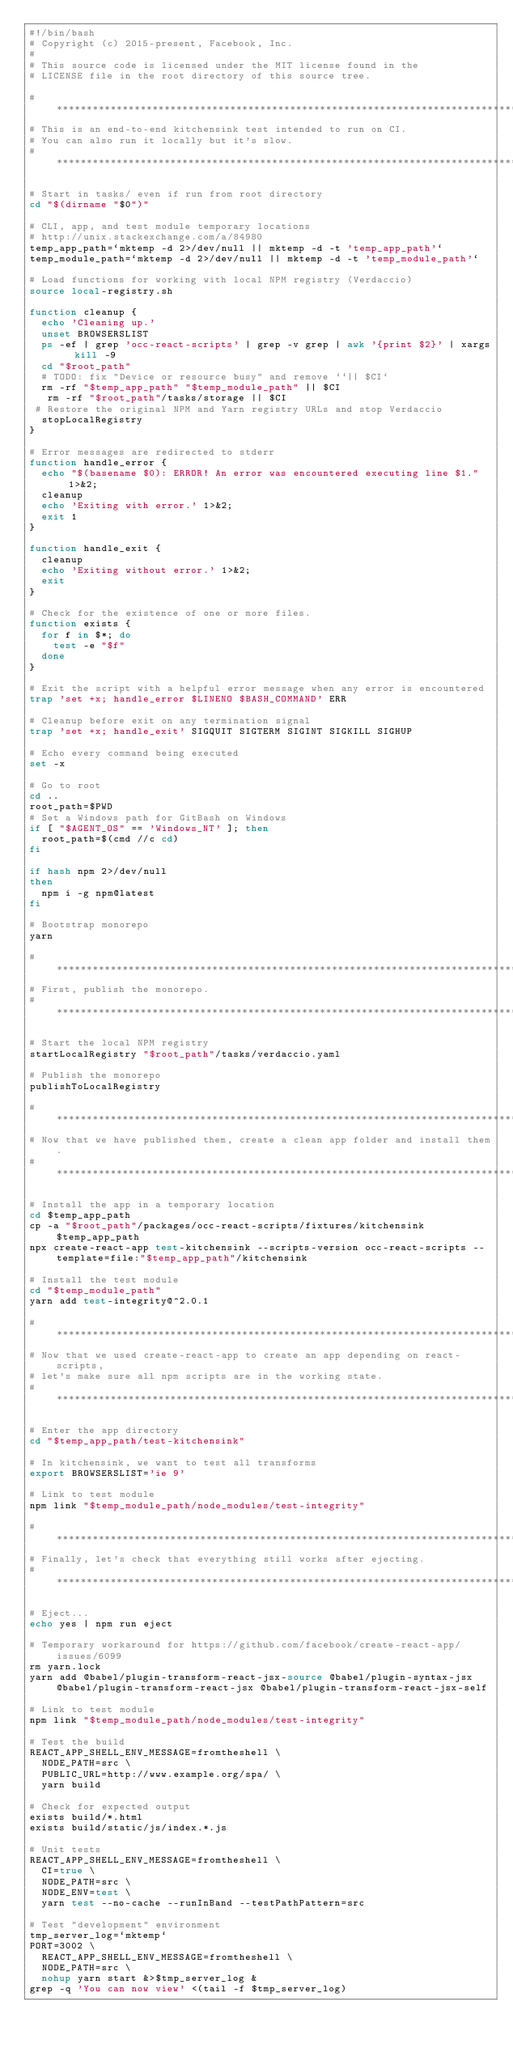<code> <loc_0><loc_0><loc_500><loc_500><_Bash_>#!/bin/bash
# Copyright (c) 2015-present, Facebook, Inc.
#
# This source code is licensed under the MIT license found in the
# LICENSE file in the root directory of this source tree.

# ******************************************************************************
# This is an end-to-end kitchensink test intended to run on CI.
# You can also run it locally but it's slow.
# ******************************************************************************

# Start in tasks/ even if run from root directory
cd "$(dirname "$0")"

# CLI, app, and test module temporary locations
# http://unix.stackexchange.com/a/84980
temp_app_path=`mktemp -d 2>/dev/null || mktemp -d -t 'temp_app_path'`
temp_module_path=`mktemp -d 2>/dev/null || mktemp -d -t 'temp_module_path'`

# Load functions for working with local NPM registry (Verdaccio)
source local-registry.sh

function cleanup {
  echo 'Cleaning up.'
  unset BROWSERSLIST
  ps -ef | grep 'occ-react-scripts' | grep -v grep | awk '{print $2}' | xargs kill -9
  cd "$root_path"
  # TODO: fix "Device or resource busy" and remove ``|| $CI`
  rm -rf "$temp_app_path" "$temp_module_path" || $CI
   rm -rf "$root_path"/tasks/storage || $CI
 # Restore the original NPM and Yarn registry URLs and stop Verdaccio
  stopLocalRegistry
}

# Error messages are redirected to stderr
function handle_error {
  echo "$(basename $0): ERROR! An error was encountered executing line $1." 1>&2;
  cleanup
  echo 'Exiting with error.' 1>&2;
  exit 1
}

function handle_exit {
  cleanup
  echo 'Exiting without error.' 1>&2;
  exit
}

# Check for the existence of one or more files.
function exists {
  for f in $*; do
    test -e "$f"
  done
}

# Exit the script with a helpful error message when any error is encountered
trap 'set +x; handle_error $LINENO $BASH_COMMAND' ERR

# Cleanup before exit on any termination signal
trap 'set +x; handle_exit' SIGQUIT SIGTERM SIGINT SIGKILL SIGHUP

# Echo every command being executed
set -x

# Go to root
cd ..
root_path=$PWD
# Set a Windows path for GitBash on Windows
if [ "$AGENT_OS" == 'Windows_NT' ]; then
  root_path=$(cmd //c cd)
fi

if hash npm 2>/dev/null
then
  npm i -g npm@latest
fi

# Bootstrap monorepo
yarn

# ******************************************************************************
# First, publish the monorepo.
# ******************************************************************************

# Start the local NPM registry
startLocalRegistry "$root_path"/tasks/verdaccio.yaml

# Publish the monorepo
publishToLocalRegistry

# ******************************************************************************
# Now that we have published them, create a clean app folder and install them.
# ******************************************************************************

# Install the app in a temporary location
cd $temp_app_path
cp -a "$root_path"/packages/occ-react-scripts/fixtures/kitchensink $temp_app_path
npx create-react-app test-kitchensink --scripts-version occ-react-scripts --template=file:"$temp_app_path"/kitchensink

# Install the test module
cd "$temp_module_path"
yarn add test-integrity@^2.0.1

# ******************************************************************************
# Now that we used create-react-app to create an app depending on react-scripts,
# let's make sure all npm scripts are in the working state.
# ******************************************************************************

# Enter the app directory
cd "$temp_app_path/test-kitchensink"

# In kitchensink, we want to test all transforms
export BROWSERSLIST='ie 9'

# Link to test module
npm link "$temp_module_path/node_modules/test-integrity"

# ******************************************************************************
# Finally, let's check that everything still works after ejecting.
# ******************************************************************************

# Eject...
echo yes | npm run eject

# Temporary workaround for https://github.com/facebook/create-react-app/issues/6099
rm yarn.lock
yarn add @babel/plugin-transform-react-jsx-source @babel/plugin-syntax-jsx @babel/plugin-transform-react-jsx @babel/plugin-transform-react-jsx-self

# Link to test module
npm link "$temp_module_path/node_modules/test-integrity"

# Test the build
REACT_APP_SHELL_ENV_MESSAGE=fromtheshell \
  NODE_PATH=src \
  PUBLIC_URL=http://www.example.org/spa/ \
  yarn build

# Check for expected output
exists build/*.html
exists build/static/js/index.*.js

# Unit tests
REACT_APP_SHELL_ENV_MESSAGE=fromtheshell \
  CI=true \
  NODE_PATH=src \
  NODE_ENV=test \
  yarn test --no-cache --runInBand --testPathPattern=src

# Test "development" environment
tmp_server_log=`mktemp`
PORT=3002 \
  REACT_APP_SHELL_ENV_MESSAGE=fromtheshell \
  NODE_PATH=src \
  nohup yarn start &>$tmp_server_log &
grep -q 'You can now view' <(tail -f $tmp_server_log)</code> 